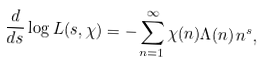<formula> <loc_0><loc_0><loc_500><loc_500>\frac { d } { d s } \log L ( s , \chi ) = - \sum _ { n = 1 } ^ { \infty } { \chi ( n ) \Lambda ( n ) } { n ^ { s } } ,</formula> 